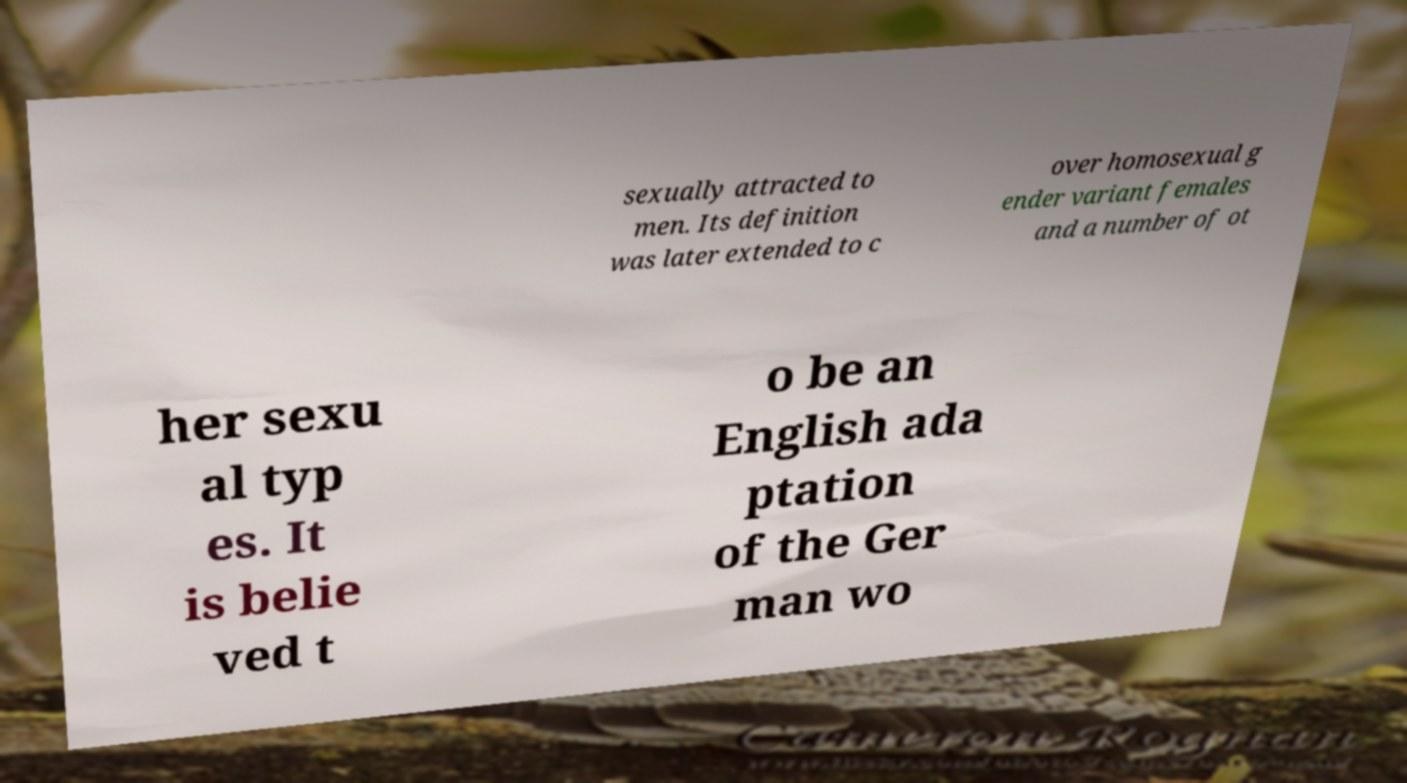Could you extract and type out the text from this image? sexually attracted to men. Its definition was later extended to c over homosexual g ender variant females and a number of ot her sexu al typ es. It is belie ved t o be an English ada ptation of the Ger man wo 